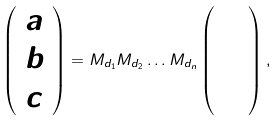Convert formula to latex. <formula><loc_0><loc_0><loc_500><loc_500>\left ( \begin{array} { l } a \\ b \\ c \end{array} \right ) = M _ { d _ { 1 } } M _ { d _ { 2 } } \dots M _ { d _ { n } } \left ( \begin{array} { l } 4 \\ 3 \\ 5 \end{array} \right ) ,</formula> 